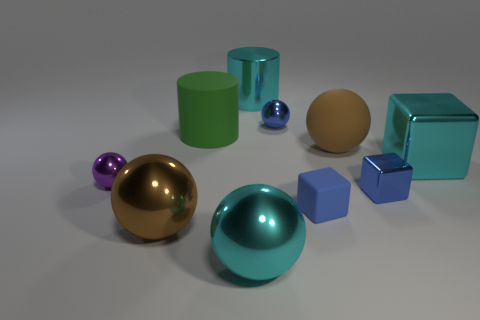Describe the big gold-colored sphere; does it seem like it has any particular texture or feature? The large gold-colored sphere in the image has a highly reflective surface that suggests it is smooth and polished. Its mirror-like texture indicates it could potentially be made of a metallic material, such as brass or gold-plated metal. Could you estimate the relative sizes of the objects? While we cannot determine the precise dimensions without additional context, we can estimate relative sizes. The gold-colored sphere and the cyan sphere are amongst the largest objects, while the small purple sphere is likely the smallest. The cubes and cylinders vary in size, positioned between the most minor and most significant items. 